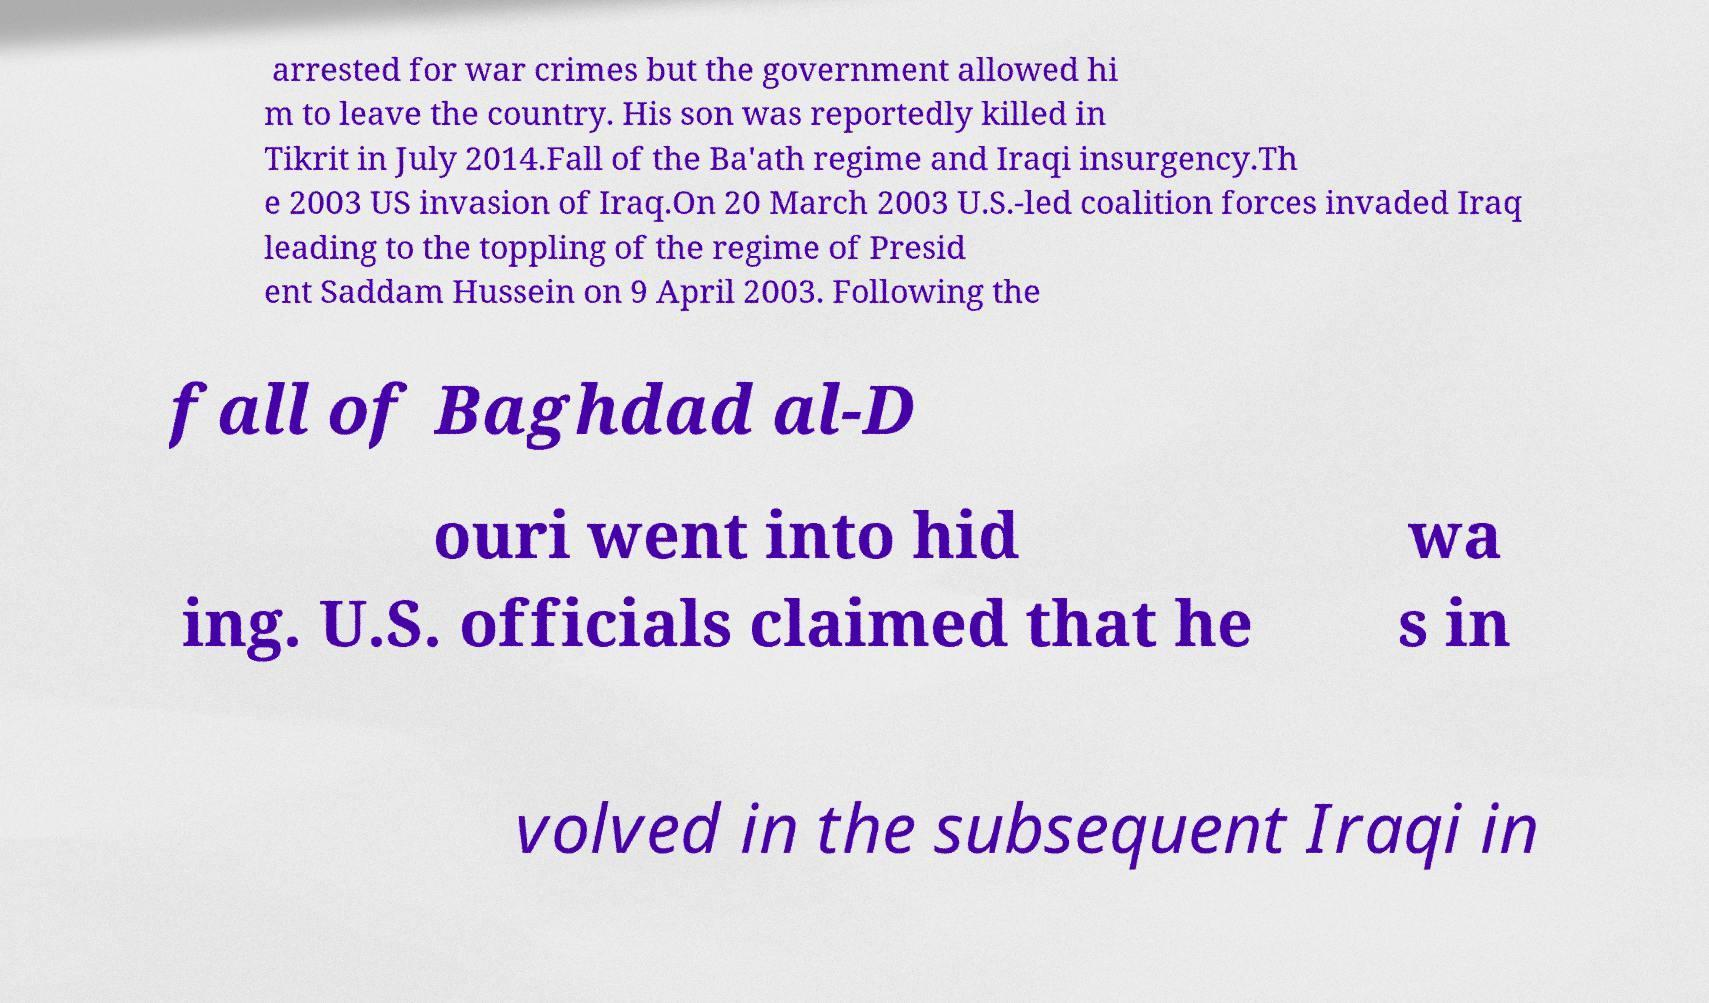Could you assist in decoding the text presented in this image and type it out clearly? arrested for war crimes but the government allowed hi m to leave the country. His son was reportedly killed in Tikrit in July 2014.Fall of the Ba'ath regime and Iraqi insurgency.Th e 2003 US invasion of Iraq.On 20 March 2003 U.S.-led coalition forces invaded Iraq leading to the toppling of the regime of Presid ent Saddam Hussein on 9 April 2003. Following the fall of Baghdad al-D ouri went into hid ing. U.S. officials claimed that he wa s in volved in the subsequent Iraqi in 